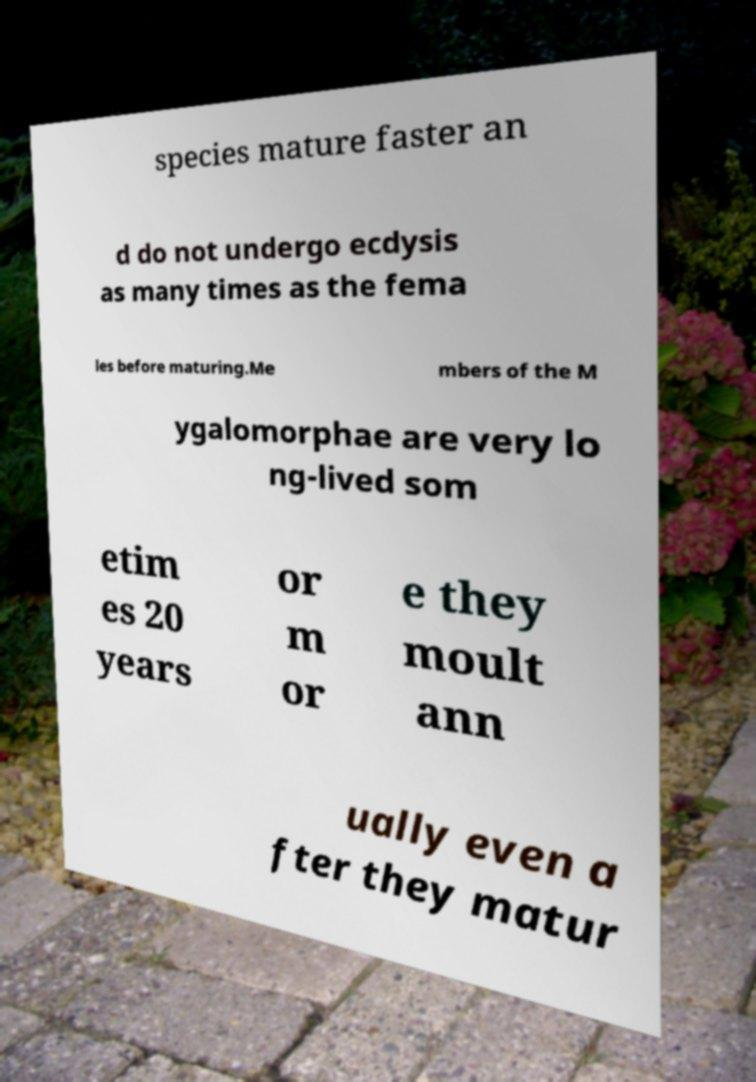Could you extract and type out the text from this image? species mature faster an d do not undergo ecdysis as many times as the fema les before maturing.Me mbers of the M ygalomorphae are very lo ng-lived som etim es 20 years or m or e they moult ann ually even a fter they matur 